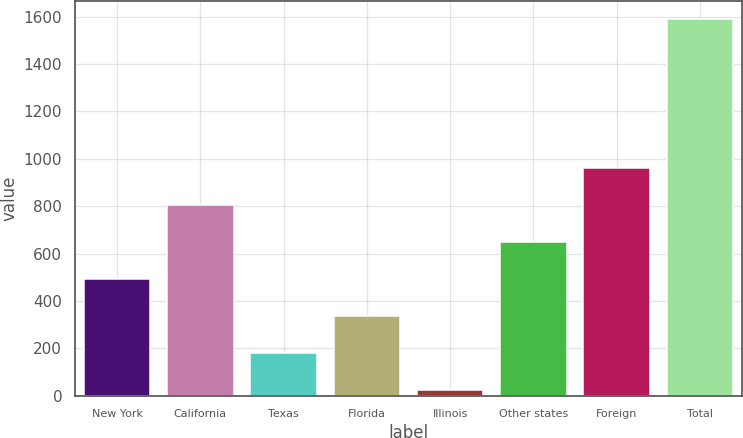Convert chart to OTSL. <chart><loc_0><loc_0><loc_500><loc_500><bar_chart><fcel>New York<fcel>California<fcel>Texas<fcel>Florida<fcel>Illinois<fcel>Other states<fcel>Foreign<fcel>Total<nl><fcel>492.8<fcel>806<fcel>179.6<fcel>336.2<fcel>23<fcel>649.4<fcel>962.6<fcel>1589<nl></chart> 